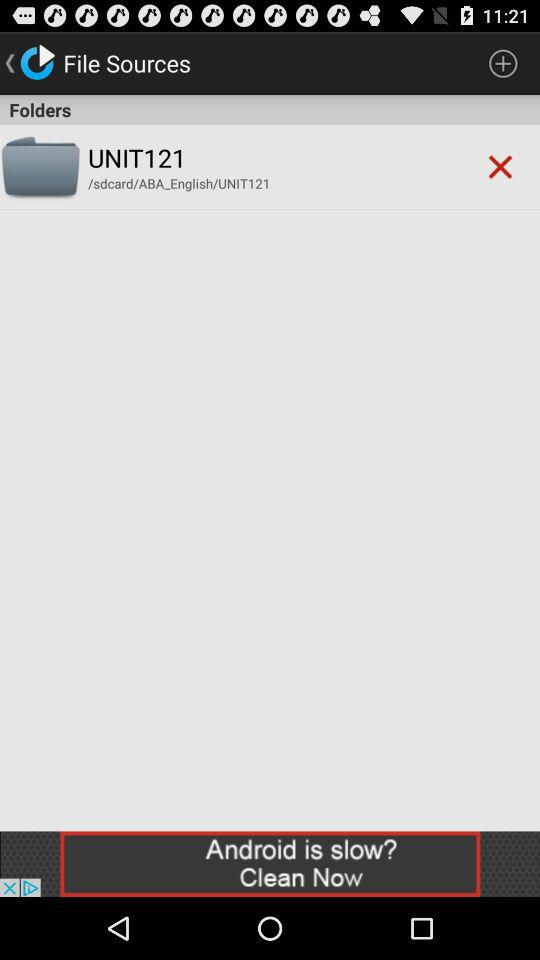What is the storage location of the folder "UNIT121"? The storage location is "/sdcard/ABA_English/UNIT121". 